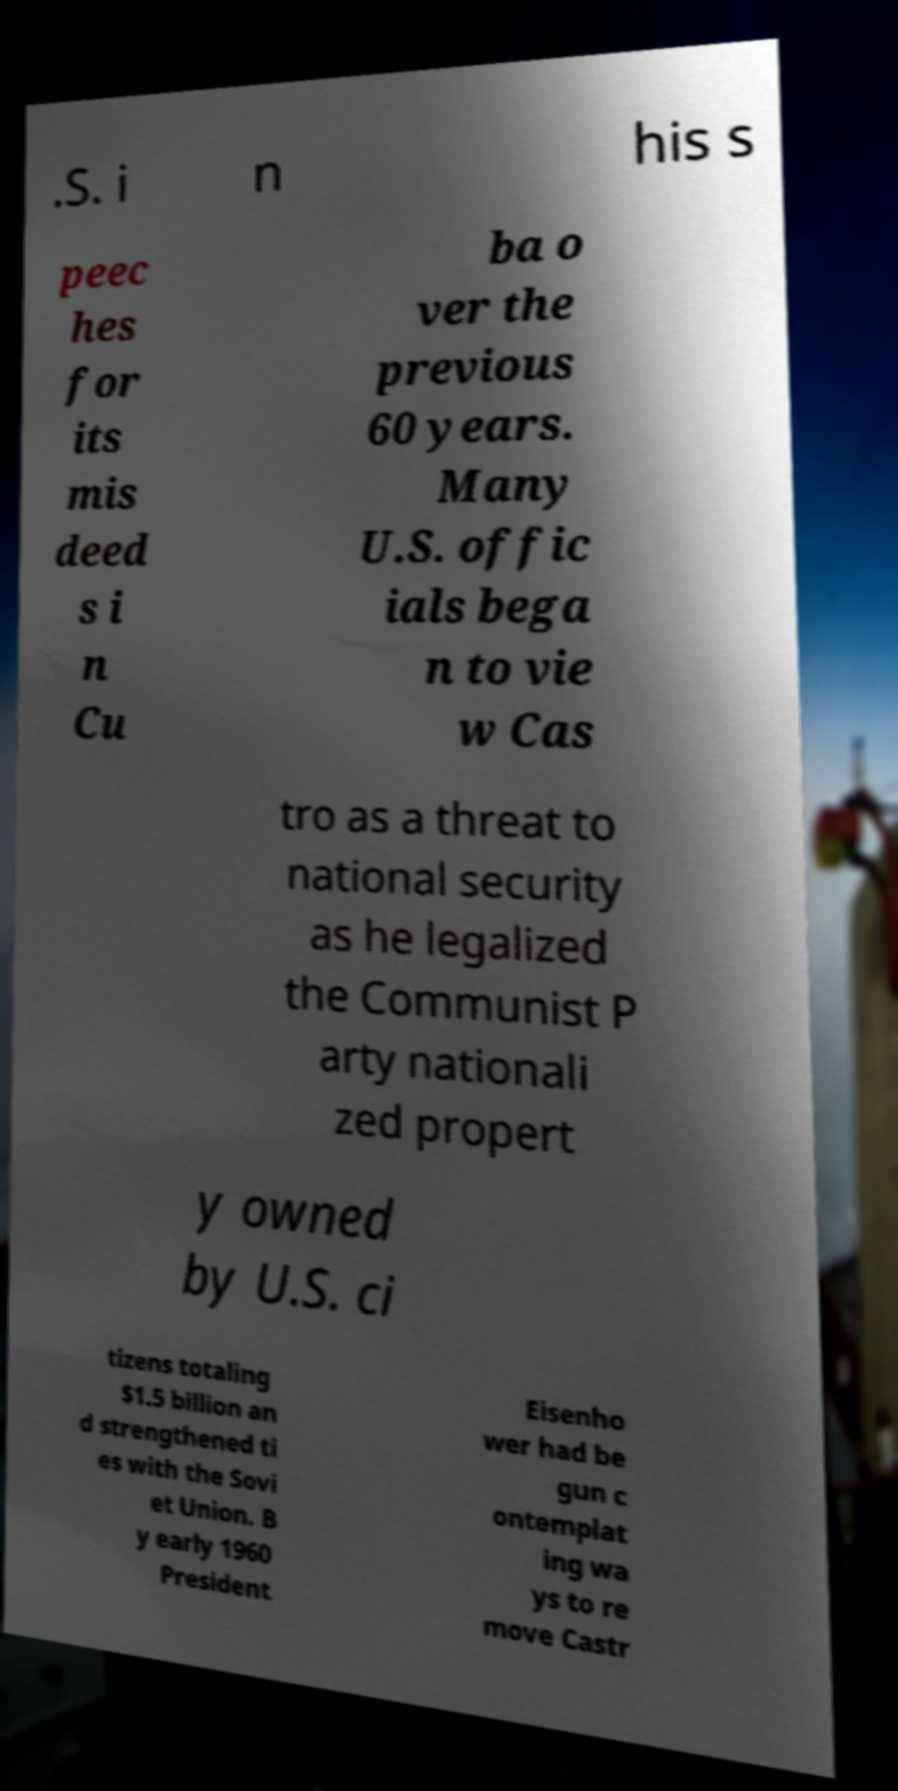For documentation purposes, I need the text within this image transcribed. Could you provide that? .S. i n his s peec hes for its mis deed s i n Cu ba o ver the previous 60 years. Many U.S. offic ials bega n to vie w Cas tro as a threat to national security as he legalized the Communist P arty nationali zed propert y owned by U.S. ci tizens totaling $1.5 billion an d strengthened ti es with the Sovi et Union. B y early 1960 President Eisenho wer had be gun c ontemplat ing wa ys to re move Castr 